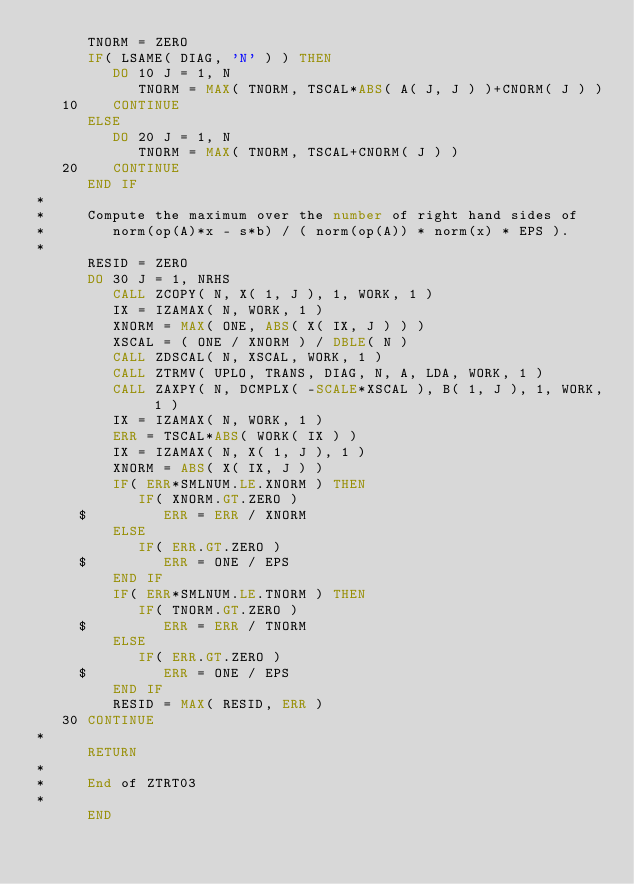<code> <loc_0><loc_0><loc_500><loc_500><_FORTRAN_>      TNORM = ZERO
      IF( LSAME( DIAG, 'N' ) ) THEN
         DO 10 J = 1, N
            TNORM = MAX( TNORM, TSCAL*ABS( A( J, J ) )+CNORM( J ) )
   10    CONTINUE
      ELSE
         DO 20 J = 1, N
            TNORM = MAX( TNORM, TSCAL+CNORM( J ) )
   20    CONTINUE
      END IF
*
*     Compute the maximum over the number of right hand sides of
*        norm(op(A)*x - s*b) / ( norm(op(A)) * norm(x) * EPS ).
*
      RESID = ZERO
      DO 30 J = 1, NRHS
         CALL ZCOPY( N, X( 1, J ), 1, WORK, 1 )
         IX = IZAMAX( N, WORK, 1 )
         XNORM = MAX( ONE, ABS( X( IX, J ) ) )
         XSCAL = ( ONE / XNORM ) / DBLE( N )
         CALL ZDSCAL( N, XSCAL, WORK, 1 )
         CALL ZTRMV( UPLO, TRANS, DIAG, N, A, LDA, WORK, 1 )
         CALL ZAXPY( N, DCMPLX( -SCALE*XSCAL ), B( 1, J ), 1, WORK, 1 )
         IX = IZAMAX( N, WORK, 1 )
         ERR = TSCAL*ABS( WORK( IX ) )
         IX = IZAMAX( N, X( 1, J ), 1 )
         XNORM = ABS( X( IX, J ) )
         IF( ERR*SMLNUM.LE.XNORM ) THEN
            IF( XNORM.GT.ZERO )
     $         ERR = ERR / XNORM
         ELSE
            IF( ERR.GT.ZERO )
     $         ERR = ONE / EPS
         END IF
         IF( ERR*SMLNUM.LE.TNORM ) THEN
            IF( TNORM.GT.ZERO )
     $         ERR = ERR / TNORM
         ELSE
            IF( ERR.GT.ZERO )
     $         ERR = ONE / EPS
         END IF
         RESID = MAX( RESID, ERR )
   30 CONTINUE
*
      RETURN
*
*     End of ZTRT03
*
      END
</code> 